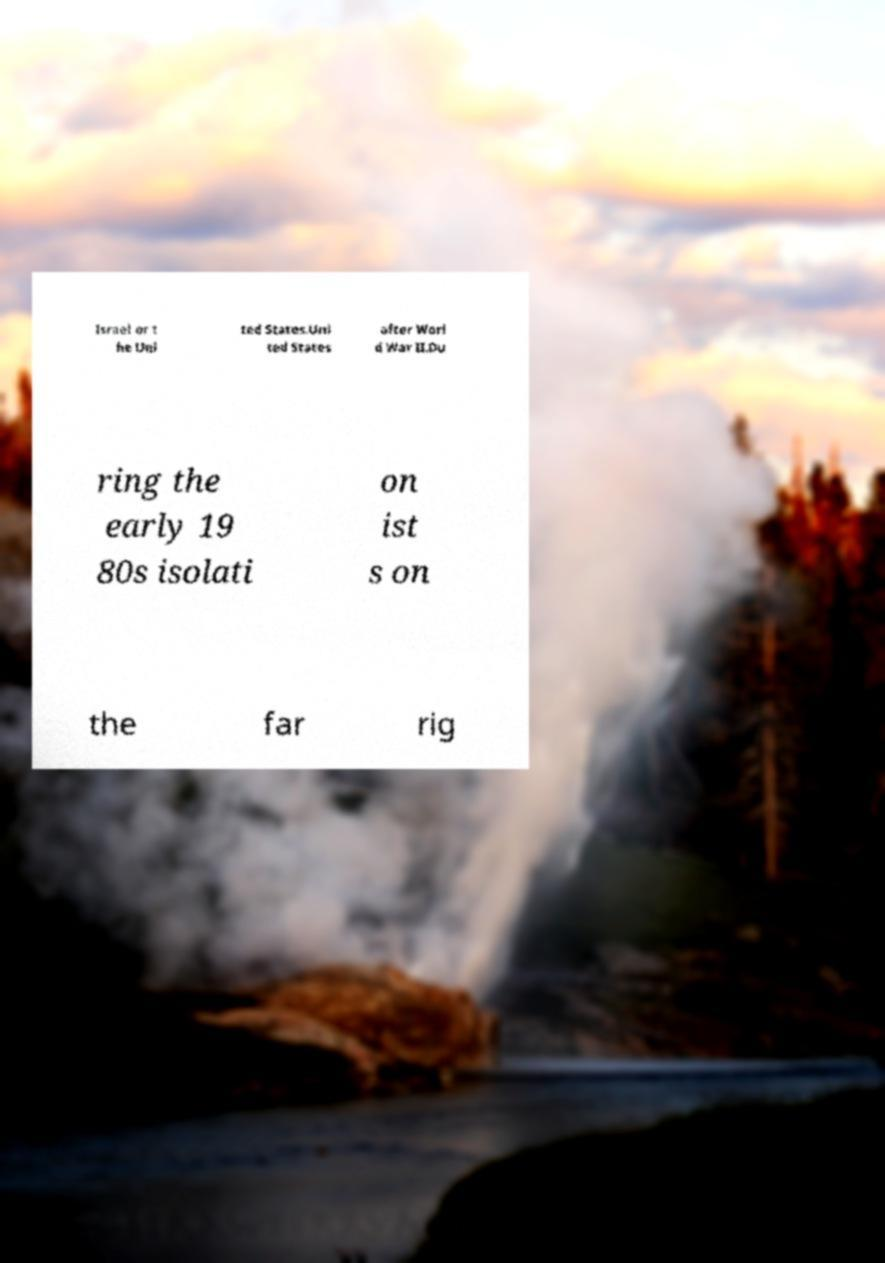For documentation purposes, I need the text within this image transcribed. Could you provide that? Israel or t he Uni ted States.Uni ted States after Worl d War II.Du ring the early 19 80s isolati on ist s on the far rig 